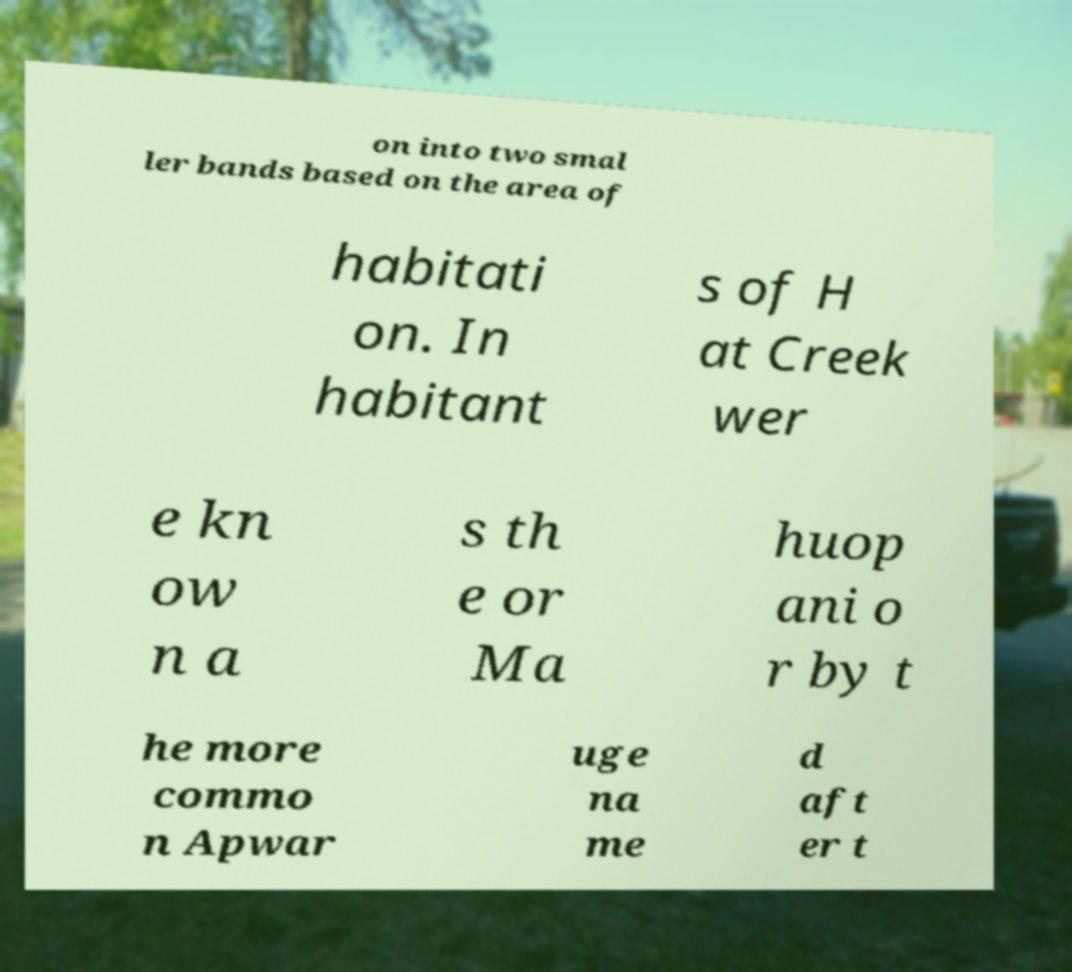Can you read and provide the text displayed in the image?This photo seems to have some interesting text. Can you extract and type it out for me? on into two smal ler bands based on the area of habitati on. In habitant s of H at Creek wer e kn ow n a s th e or Ma huop ani o r by t he more commo n Apwar uge na me d aft er t 